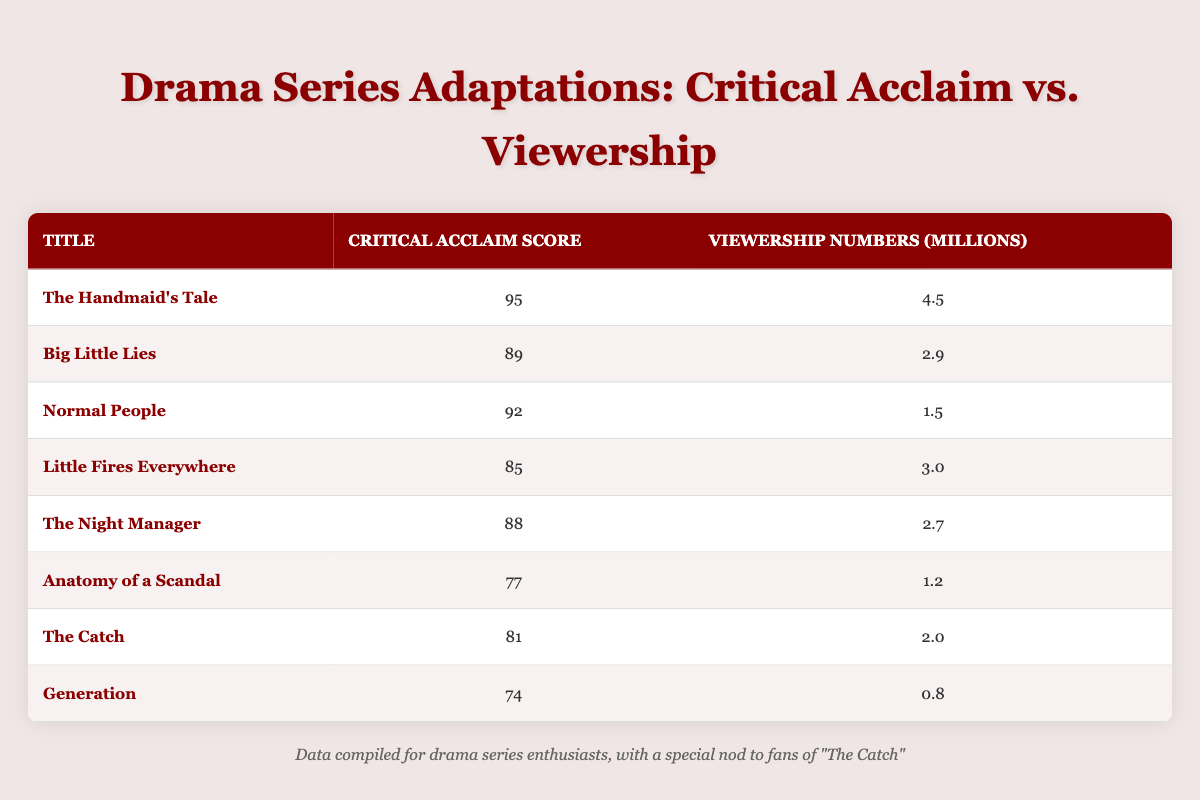What is the critical acclaim score for "The Handmaid's Tale"? "The Handmaid's Tale" has a critical acclaim score listed in the table, which can be found directly in the second column next to its title. The score is 95.
Answer: 95 Which drama series adaptation has the highest viewership numbers? By looking at the viewership numbers in the third column, we see that "The Handmaid's Tale" has the highest figure, which is 4.5 million.
Answer: 4.5 million What is the average critical acclaim score of all the series listed? To find the average, we sum all the critical acclaim scores: (95 + 89 + 92 + 85 + 88 + 77 + 81 + 74) = 696. There are 8 series, so the average is 696/8 = 87.
Answer: 87 Is "Generation" ranked higher in critical acclaim than "The Catch"? Looking at the critical acclaim scores, "Generation" has a score of 74 and "The Catch" has a score of 81. Since 74 is less than 81, "Generation" is ranked lower.
Answer: No What is the difference in viewership numbers between "Little Fires Everywhere" and "The Night Manager"? From the table, "Little Fires Everywhere" has 3.0 million and "The Night Manager" has 2.7 million in viewership numbers. The difference is calculated as 3.0 - 2.7 = 0.3 million.
Answer: 0.3 million Which two series adaptations combined have a critical acclaim score of more than 170? Comparing the scores, if we take "The Handmaid's Tale" (95) and "Normal People" (92), their combined score is 95 + 92 = 187, which is more than 170. We could also use "The Handmaid's Tale" and "Big Little Lies" (89) for a total of 184, confirming that several combinations work.
Answer: Yes What is the total viewership for the bottom three series based on watch numbers? The bottom three series are "Generation" (0.8 million), "Anatomy of a Scandal" (1.2 million), and "Normal People" (1.5 million). The total is 0.8 + 1.2 + 1.5 = 3.5 million.
Answer: 3.5 million Which series has a critical acclaim score immediately below that of "Little Fires Everywhere"? "Little Fires Everywhere" has a score of 85. The next lowest score in the table is that of "The Night Manager," which has a score of 88. However, since we are looking for a lower score, we check "The Catch," which is 81. Thus, "The Catch" fits the criteria.
Answer: The Catch 